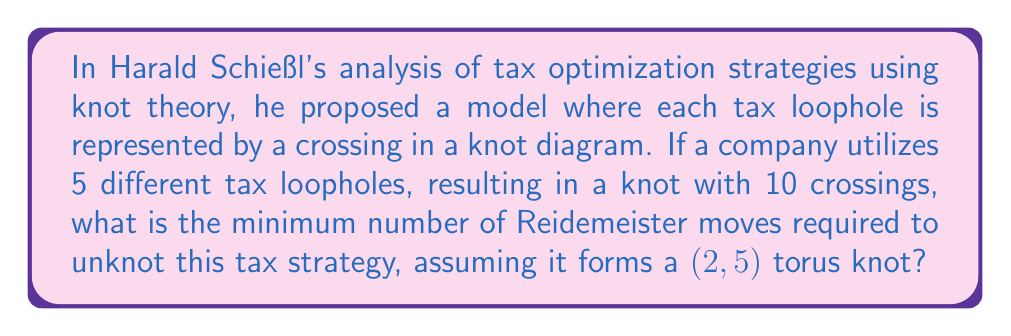Can you solve this math problem? To solve this problem, we need to follow these steps:

1. Understand the representation:
   - Each tax loophole is represented by a crossing in the knot diagram
   - The company uses 5 loopholes, resulting in a knot with 10 crossings
   - The knot forms a (2,5) torus knot

2. Recall properties of (2,5) torus knots:
   - A (2,5) torus knot has a crossing number of 5
   - It is a non-trivial knot that cannot be unknotted without using Reidemeister moves

3. Calculate the difference in crossings:
   - The given knot has 10 crossings
   - The standard (2,5) torus knot has 5 crossings
   - Difference: $10 - 5 = 5$ crossings

4. Determine the minimum number of Reidemeister moves:
   - Each Reidemeister move of type I can remove or add one crossing
   - To reduce from 10 to 5 crossings, we need at least 5 Reidemeister moves of type I
   - After reducing to 5 crossings, we have the standard (2,5) torus knot

5. Consider unknotting the (2,5) torus knot:
   - The unknotting number of a (2,5) torus knot is 2
   - This means we need at least 2 additional Reidemeister moves to unknot it completely

6. Sum up the total number of moves:
   - Minimum moves = Moves to reduce crossings + Moves to unknot
   - Minimum moves = $5 + 2 = 7$

Therefore, the minimum number of Reidemeister moves required to unknot this tax strategy is 7.
Answer: 7 Reidemeister moves 